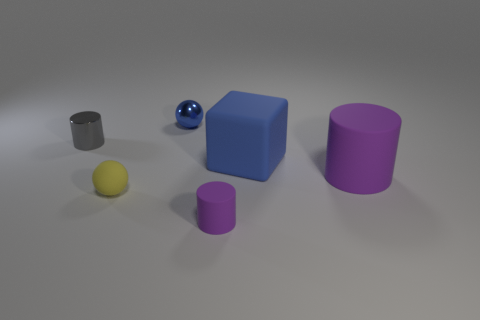Add 1 tiny blue blocks. How many objects exist? 7 Subtract all balls. How many objects are left? 4 Subtract all balls. Subtract all cyan rubber cylinders. How many objects are left? 4 Add 1 small metallic spheres. How many small metallic spheres are left? 2 Add 2 tiny blue objects. How many tiny blue objects exist? 3 Subtract 0 green cylinders. How many objects are left? 6 